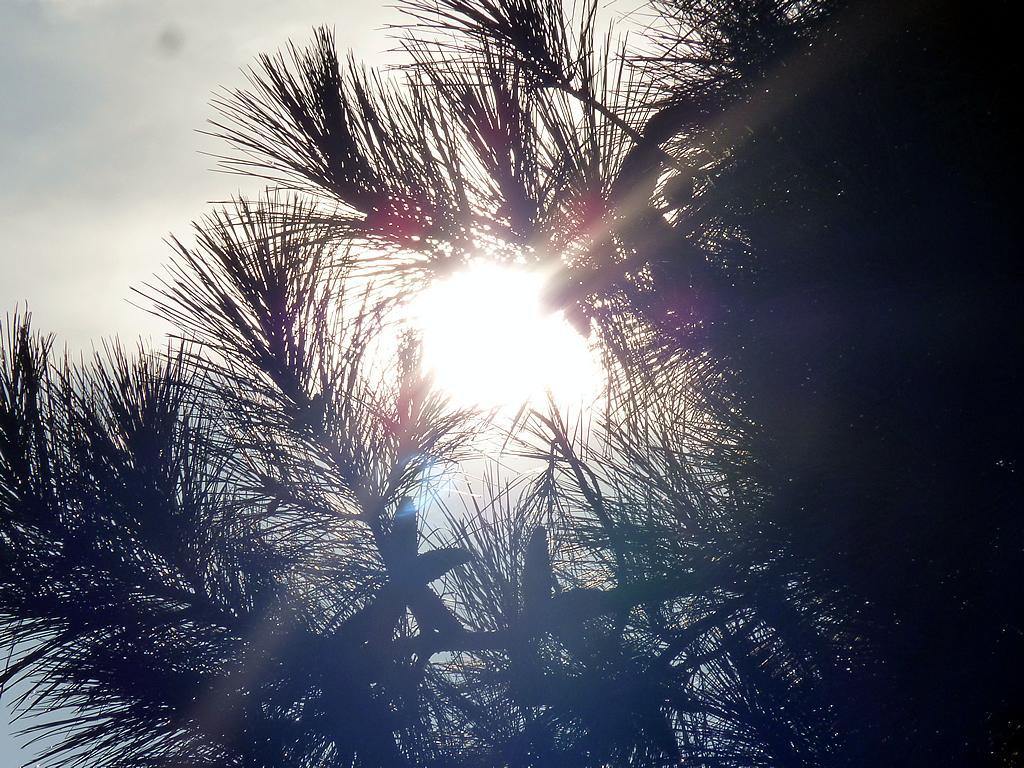Describe this image in one or two sentences. In this image I can see the sun through the tree branches. I can see the sky in the top left corner. I can see the tree in the right bottom corner. I can see the sun in the center of the image. 